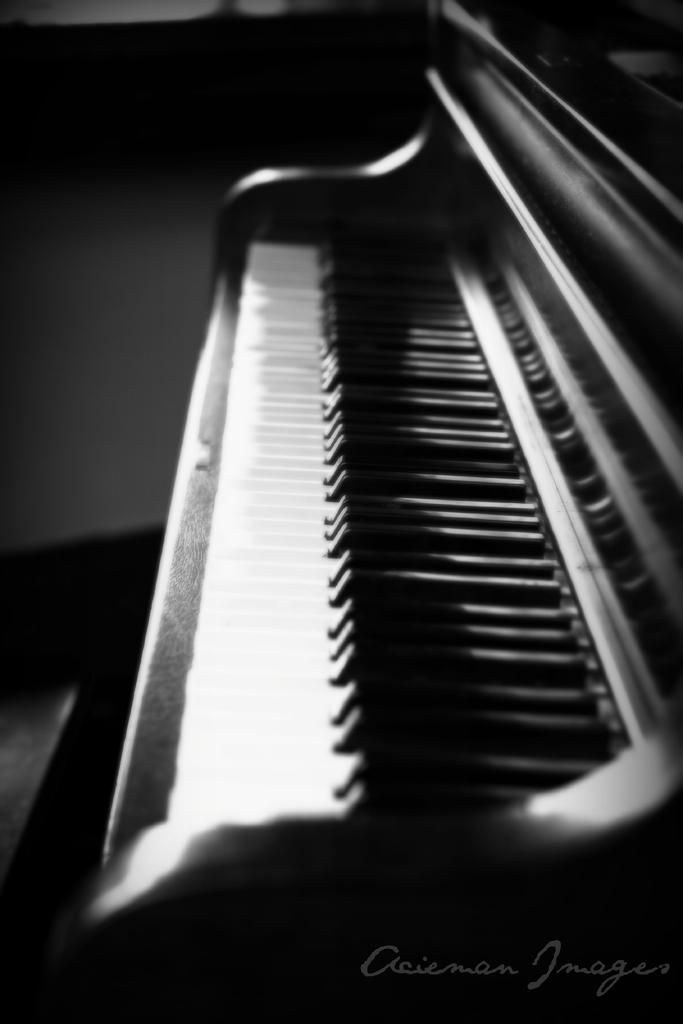What musical instrument is present in the image? There is a piano in the image. What part of the piano is visible in the image? The keys of the piano are visible. Where was the image taken? The image was taken inside a house. What type of guitar is being played in the image? There is no guitar present in the image; it features a piano. What is the desire of the person playing the guitar in the image? There is no person playing a guitar in the image, as it only shows a piano. 